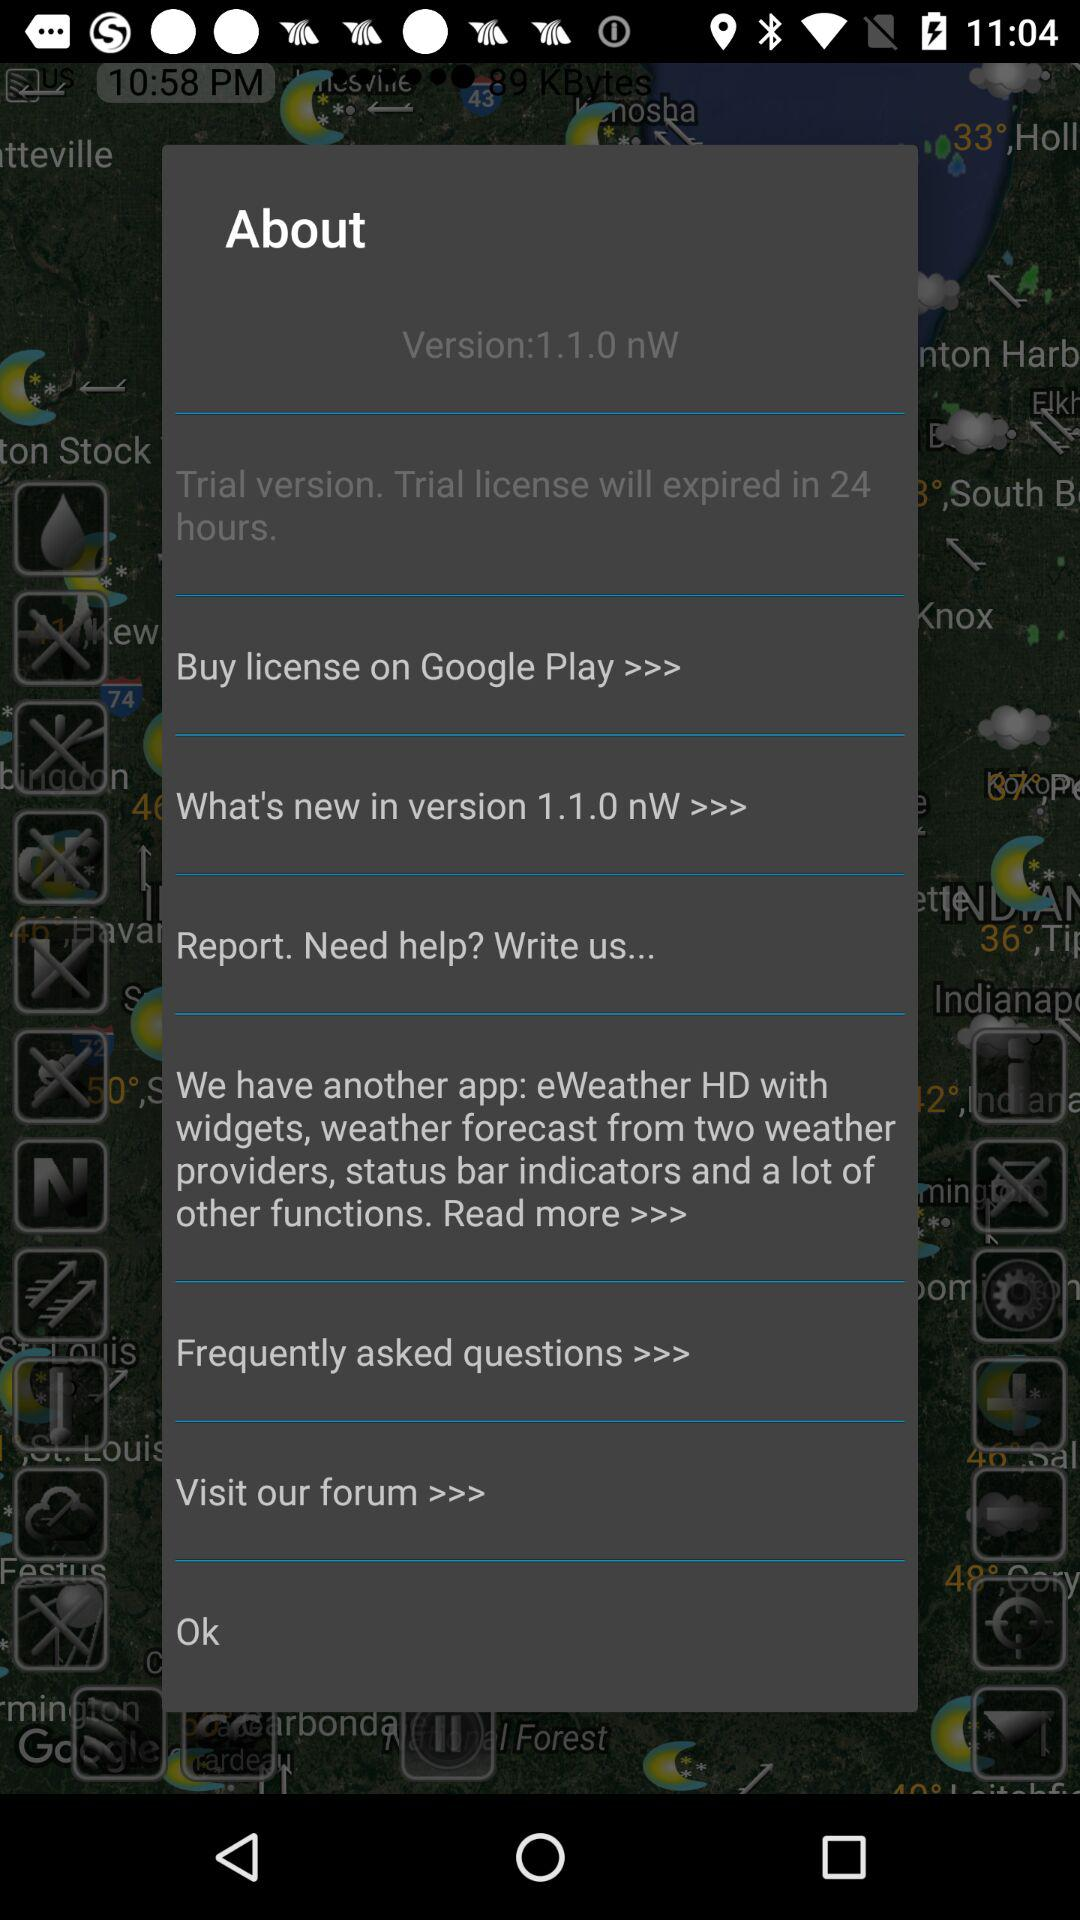What is the version number? The version number is 1.1.0 nW. 